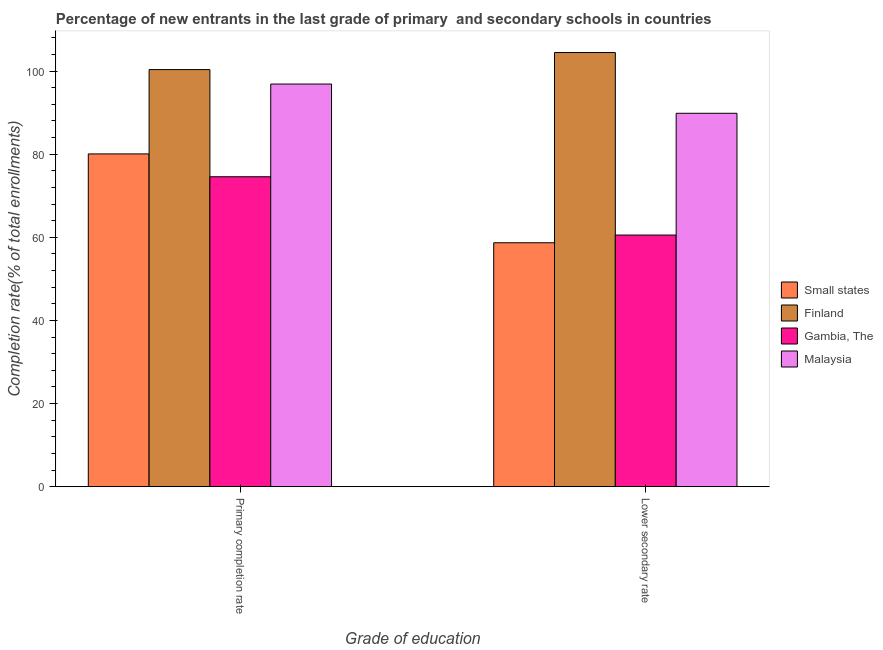How many groups of bars are there?
Offer a terse response. 2. Are the number of bars per tick equal to the number of legend labels?
Make the answer very short. Yes. Are the number of bars on each tick of the X-axis equal?
Ensure brevity in your answer.  Yes. How many bars are there on the 2nd tick from the right?
Your answer should be compact. 4. What is the label of the 1st group of bars from the left?
Provide a short and direct response. Primary completion rate. What is the completion rate in secondary schools in Gambia, The?
Offer a very short reply. 60.54. Across all countries, what is the maximum completion rate in primary schools?
Make the answer very short. 100.35. Across all countries, what is the minimum completion rate in secondary schools?
Provide a succinct answer. 58.69. In which country was the completion rate in secondary schools maximum?
Offer a terse response. Finland. In which country was the completion rate in secondary schools minimum?
Offer a very short reply. Small states. What is the total completion rate in secondary schools in the graph?
Your answer should be compact. 313.52. What is the difference between the completion rate in secondary schools in Small states and that in Gambia, The?
Your answer should be compact. -1.85. What is the difference between the completion rate in primary schools in Finland and the completion rate in secondary schools in Gambia, The?
Make the answer very short. 39.81. What is the average completion rate in secondary schools per country?
Keep it short and to the point. 78.38. What is the difference between the completion rate in primary schools and completion rate in secondary schools in Small states?
Keep it short and to the point. 21.37. In how many countries, is the completion rate in primary schools greater than 16 %?
Your answer should be very brief. 4. What is the ratio of the completion rate in primary schools in Small states to that in Gambia, The?
Ensure brevity in your answer.  1.07. Is the completion rate in primary schools in Finland less than that in Small states?
Provide a succinct answer. No. In how many countries, is the completion rate in secondary schools greater than the average completion rate in secondary schools taken over all countries?
Give a very brief answer. 2. What does the 4th bar from the right in Lower secondary rate represents?
Your answer should be compact. Small states. How many countries are there in the graph?
Give a very brief answer. 4. Are the values on the major ticks of Y-axis written in scientific E-notation?
Your answer should be compact. No. Does the graph contain any zero values?
Your answer should be very brief. No. Where does the legend appear in the graph?
Provide a succinct answer. Center right. What is the title of the graph?
Offer a very short reply. Percentage of new entrants in the last grade of primary  and secondary schools in countries. Does "Curacao" appear as one of the legend labels in the graph?
Give a very brief answer. No. What is the label or title of the X-axis?
Provide a short and direct response. Grade of education. What is the label or title of the Y-axis?
Make the answer very short. Completion rate(% of total enrollments). What is the Completion rate(% of total enrollments) in Small states in Primary completion rate?
Provide a short and direct response. 80.06. What is the Completion rate(% of total enrollments) of Finland in Primary completion rate?
Your response must be concise. 100.35. What is the Completion rate(% of total enrollments) in Gambia, The in Primary completion rate?
Keep it short and to the point. 74.57. What is the Completion rate(% of total enrollments) of Malaysia in Primary completion rate?
Offer a very short reply. 96.87. What is the Completion rate(% of total enrollments) in Small states in Lower secondary rate?
Give a very brief answer. 58.69. What is the Completion rate(% of total enrollments) of Finland in Lower secondary rate?
Provide a short and direct response. 104.45. What is the Completion rate(% of total enrollments) in Gambia, The in Lower secondary rate?
Make the answer very short. 60.54. What is the Completion rate(% of total enrollments) of Malaysia in Lower secondary rate?
Offer a terse response. 89.84. Across all Grade of education, what is the maximum Completion rate(% of total enrollments) in Small states?
Ensure brevity in your answer.  80.06. Across all Grade of education, what is the maximum Completion rate(% of total enrollments) of Finland?
Make the answer very short. 104.45. Across all Grade of education, what is the maximum Completion rate(% of total enrollments) of Gambia, The?
Ensure brevity in your answer.  74.57. Across all Grade of education, what is the maximum Completion rate(% of total enrollments) in Malaysia?
Make the answer very short. 96.87. Across all Grade of education, what is the minimum Completion rate(% of total enrollments) in Small states?
Your answer should be very brief. 58.69. Across all Grade of education, what is the minimum Completion rate(% of total enrollments) in Finland?
Provide a short and direct response. 100.35. Across all Grade of education, what is the minimum Completion rate(% of total enrollments) in Gambia, The?
Make the answer very short. 60.54. Across all Grade of education, what is the minimum Completion rate(% of total enrollments) of Malaysia?
Your answer should be compact. 89.84. What is the total Completion rate(% of total enrollments) in Small states in the graph?
Offer a very short reply. 138.75. What is the total Completion rate(% of total enrollments) of Finland in the graph?
Ensure brevity in your answer.  204.8. What is the total Completion rate(% of total enrollments) of Gambia, The in the graph?
Your answer should be very brief. 135.11. What is the total Completion rate(% of total enrollments) in Malaysia in the graph?
Keep it short and to the point. 186.71. What is the difference between the Completion rate(% of total enrollments) of Small states in Primary completion rate and that in Lower secondary rate?
Your answer should be compact. 21.37. What is the difference between the Completion rate(% of total enrollments) in Finland in Primary completion rate and that in Lower secondary rate?
Provide a short and direct response. -4.1. What is the difference between the Completion rate(% of total enrollments) of Gambia, The in Primary completion rate and that in Lower secondary rate?
Make the answer very short. 14.03. What is the difference between the Completion rate(% of total enrollments) of Malaysia in Primary completion rate and that in Lower secondary rate?
Ensure brevity in your answer.  7.03. What is the difference between the Completion rate(% of total enrollments) of Small states in Primary completion rate and the Completion rate(% of total enrollments) of Finland in Lower secondary rate?
Give a very brief answer. -24.39. What is the difference between the Completion rate(% of total enrollments) of Small states in Primary completion rate and the Completion rate(% of total enrollments) of Gambia, The in Lower secondary rate?
Keep it short and to the point. 19.52. What is the difference between the Completion rate(% of total enrollments) of Small states in Primary completion rate and the Completion rate(% of total enrollments) of Malaysia in Lower secondary rate?
Offer a terse response. -9.77. What is the difference between the Completion rate(% of total enrollments) of Finland in Primary completion rate and the Completion rate(% of total enrollments) of Gambia, The in Lower secondary rate?
Provide a short and direct response. 39.81. What is the difference between the Completion rate(% of total enrollments) of Finland in Primary completion rate and the Completion rate(% of total enrollments) of Malaysia in Lower secondary rate?
Your answer should be very brief. 10.51. What is the difference between the Completion rate(% of total enrollments) in Gambia, The in Primary completion rate and the Completion rate(% of total enrollments) in Malaysia in Lower secondary rate?
Your answer should be compact. -15.27. What is the average Completion rate(% of total enrollments) in Small states per Grade of education?
Give a very brief answer. 69.38. What is the average Completion rate(% of total enrollments) in Finland per Grade of education?
Give a very brief answer. 102.4. What is the average Completion rate(% of total enrollments) of Gambia, The per Grade of education?
Your response must be concise. 67.56. What is the average Completion rate(% of total enrollments) of Malaysia per Grade of education?
Make the answer very short. 93.35. What is the difference between the Completion rate(% of total enrollments) in Small states and Completion rate(% of total enrollments) in Finland in Primary completion rate?
Ensure brevity in your answer.  -20.29. What is the difference between the Completion rate(% of total enrollments) in Small states and Completion rate(% of total enrollments) in Gambia, The in Primary completion rate?
Ensure brevity in your answer.  5.49. What is the difference between the Completion rate(% of total enrollments) in Small states and Completion rate(% of total enrollments) in Malaysia in Primary completion rate?
Keep it short and to the point. -16.81. What is the difference between the Completion rate(% of total enrollments) in Finland and Completion rate(% of total enrollments) in Gambia, The in Primary completion rate?
Give a very brief answer. 25.78. What is the difference between the Completion rate(% of total enrollments) of Finland and Completion rate(% of total enrollments) of Malaysia in Primary completion rate?
Offer a very short reply. 3.48. What is the difference between the Completion rate(% of total enrollments) of Gambia, The and Completion rate(% of total enrollments) of Malaysia in Primary completion rate?
Your answer should be very brief. -22.3. What is the difference between the Completion rate(% of total enrollments) of Small states and Completion rate(% of total enrollments) of Finland in Lower secondary rate?
Keep it short and to the point. -45.76. What is the difference between the Completion rate(% of total enrollments) of Small states and Completion rate(% of total enrollments) of Gambia, The in Lower secondary rate?
Provide a short and direct response. -1.85. What is the difference between the Completion rate(% of total enrollments) in Small states and Completion rate(% of total enrollments) in Malaysia in Lower secondary rate?
Provide a short and direct response. -31.15. What is the difference between the Completion rate(% of total enrollments) in Finland and Completion rate(% of total enrollments) in Gambia, The in Lower secondary rate?
Offer a very short reply. 43.91. What is the difference between the Completion rate(% of total enrollments) in Finland and Completion rate(% of total enrollments) in Malaysia in Lower secondary rate?
Your response must be concise. 14.61. What is the difference between the Completion rate(% of total enrollments) of Gambia, The and Completion rate(% of total enrollments) of Malaysia in Lower secondary rate?
Make the answer very short. -29.29. What is the ratio of the Completion rate(% of total enrollments) of Small states in Primary completion rate to that in Lower secondary rate?
Keep it short and to the point. 1.36. What is the ratio of the Completion rate(% of total enrollments) in Finland in Primary completion rate to that in Lower secondary rate?
Your answer should be very brief. 0.96. What is the ratio of the Completion rate(% of total enrollments) of Gambia, The in Primary completion rate to that in Lower secondary rate?
Offer a terse response. 1.23. What is the ratio of the Completion rate(% of total enrollments) in Malaysia in Primary completion rate to that in Lower secondary rate?
Ensure brevity in your answer.  1.08. What is the difference between the highest and the second highest Completion rate(% of total enrollments) in Small states?
Provide a succinct answer. 21.37. What is the difference between the highest and the second highest Completion rate(% of total enrollments) in Finland?
Offer a very short reply. 4.1. What is the difference between the highest and the second highest Completion rate(% of total enrollments) of Gambia, The?
Ensure brevity in your answer.  14.03. What is the difference between the highest and the second highest Completion rate(% of total enrollments) of Malaysia?
Offer a very short reply. 7.03. What is the difference between the highest and the lowest Completion rate(% of total enrollments) in Small states?
Give a very brief answer. 21.37. What is the difference between the highest and the lowest Completion rate(% of total enrollments) in Finland?
Provide a succinct answer. 4.1. What is the difference between the highest and the lowest Completion rate(% of total enrollments) in Gambia, The?
Your response must be concise. 14.03. What is the difference between the highest and the lowest Completion rate(% of total enrollments) in Malaysia?
Provide a succinct answer. 7.03. 